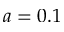<formula> <loc_0><loc_0><loc_500><loc_500>a = 0 . 1</formula> 